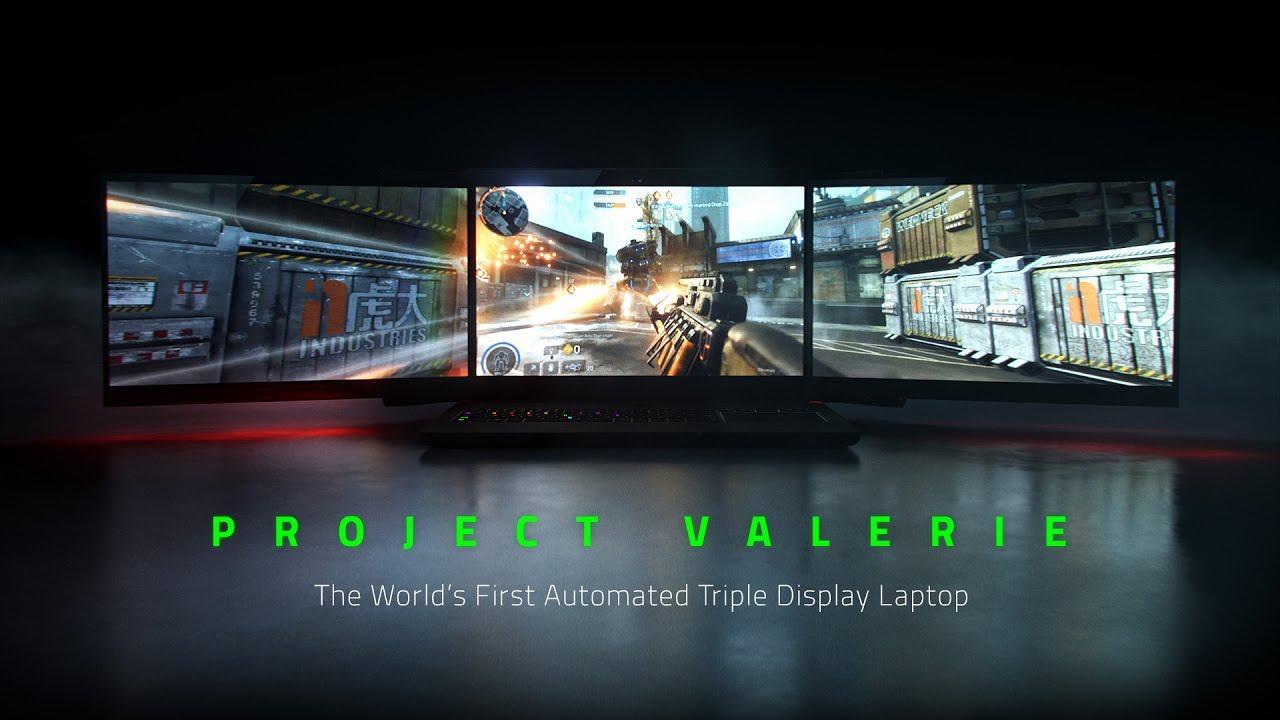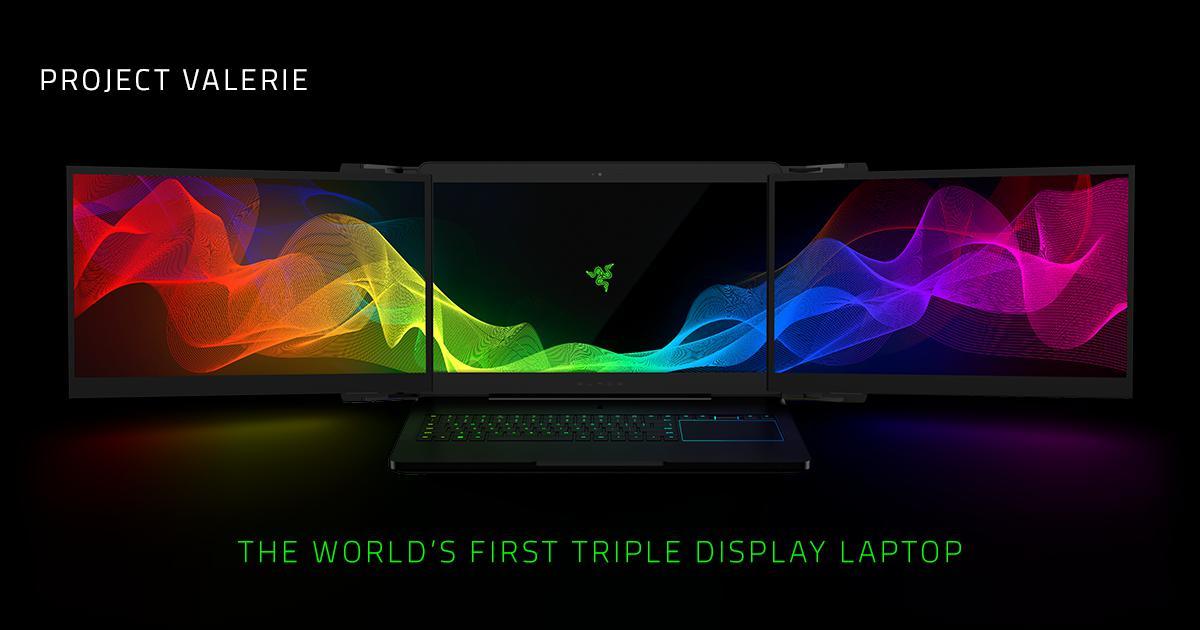The first image is the image on the left, the second image is the image on the right. Analyze the images presented: Is the assertion "Each image shows a mostly head-on view of a triple-display laptop on a brownish desk, projecting a video game scene." valid? Answer yes or no. No. The first image is the image on the left, the second image is the image on the right. Assess this claim about the two images: "The computer mouse in one of the image has a purple triangle light on it.". Correct or not? Answer yes or no. No. 